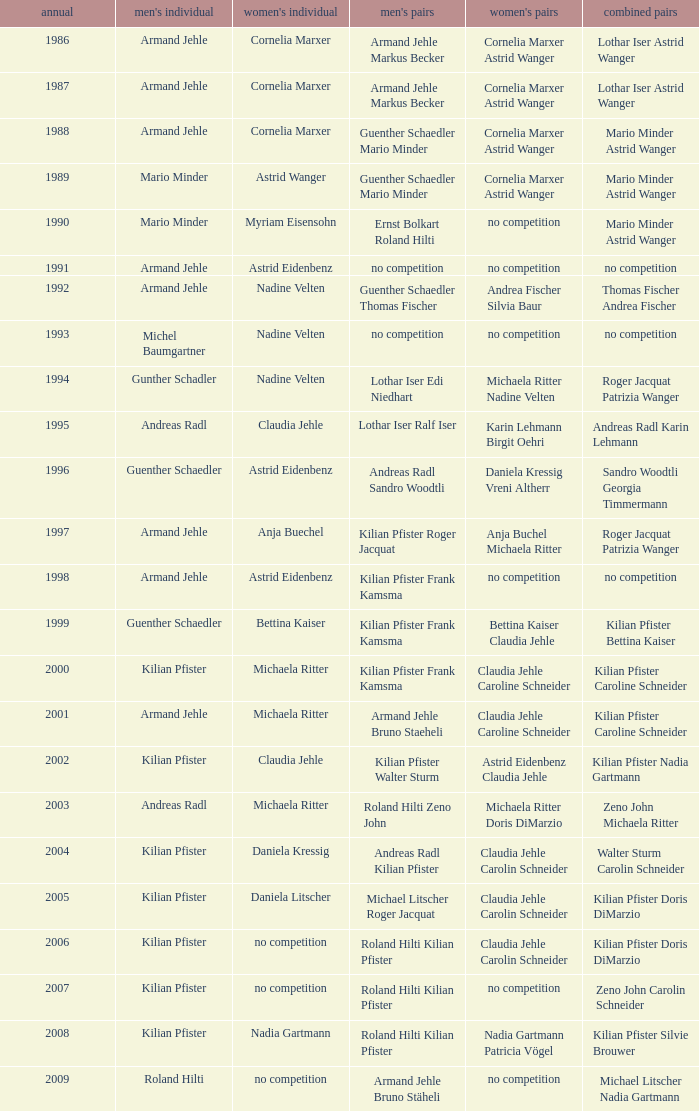In the year 2006, the womens singles had no competition and the mens doubles were roland hilti kilian pfister, what were the womens doubles Claudia Jehle Carolin Schneider. 